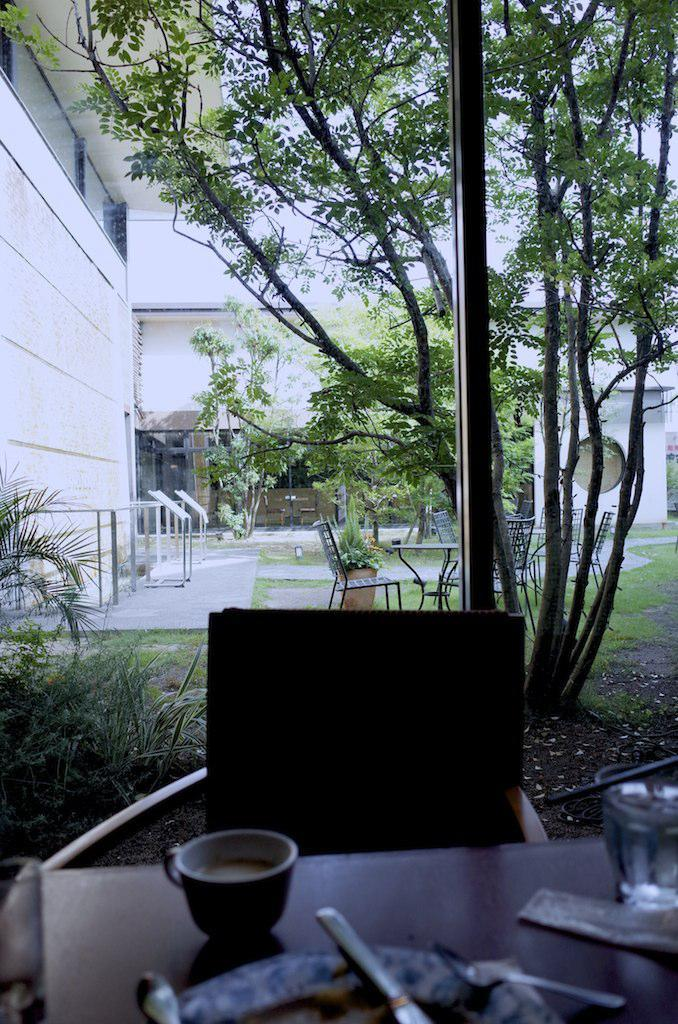What piece of furniture is present in the image? There is a table in the image. What is placed on the table? There is a cup and plates on the table. What type of seating is visible in the image? There is a chair in the image. What natural element can be seen in the image? There is a tree in the image. What man-made structure is present in the image? There is a building in the image. How does the group of people feel about the ongoing war in the image? There is no group of people or mention of a war present in the image. 